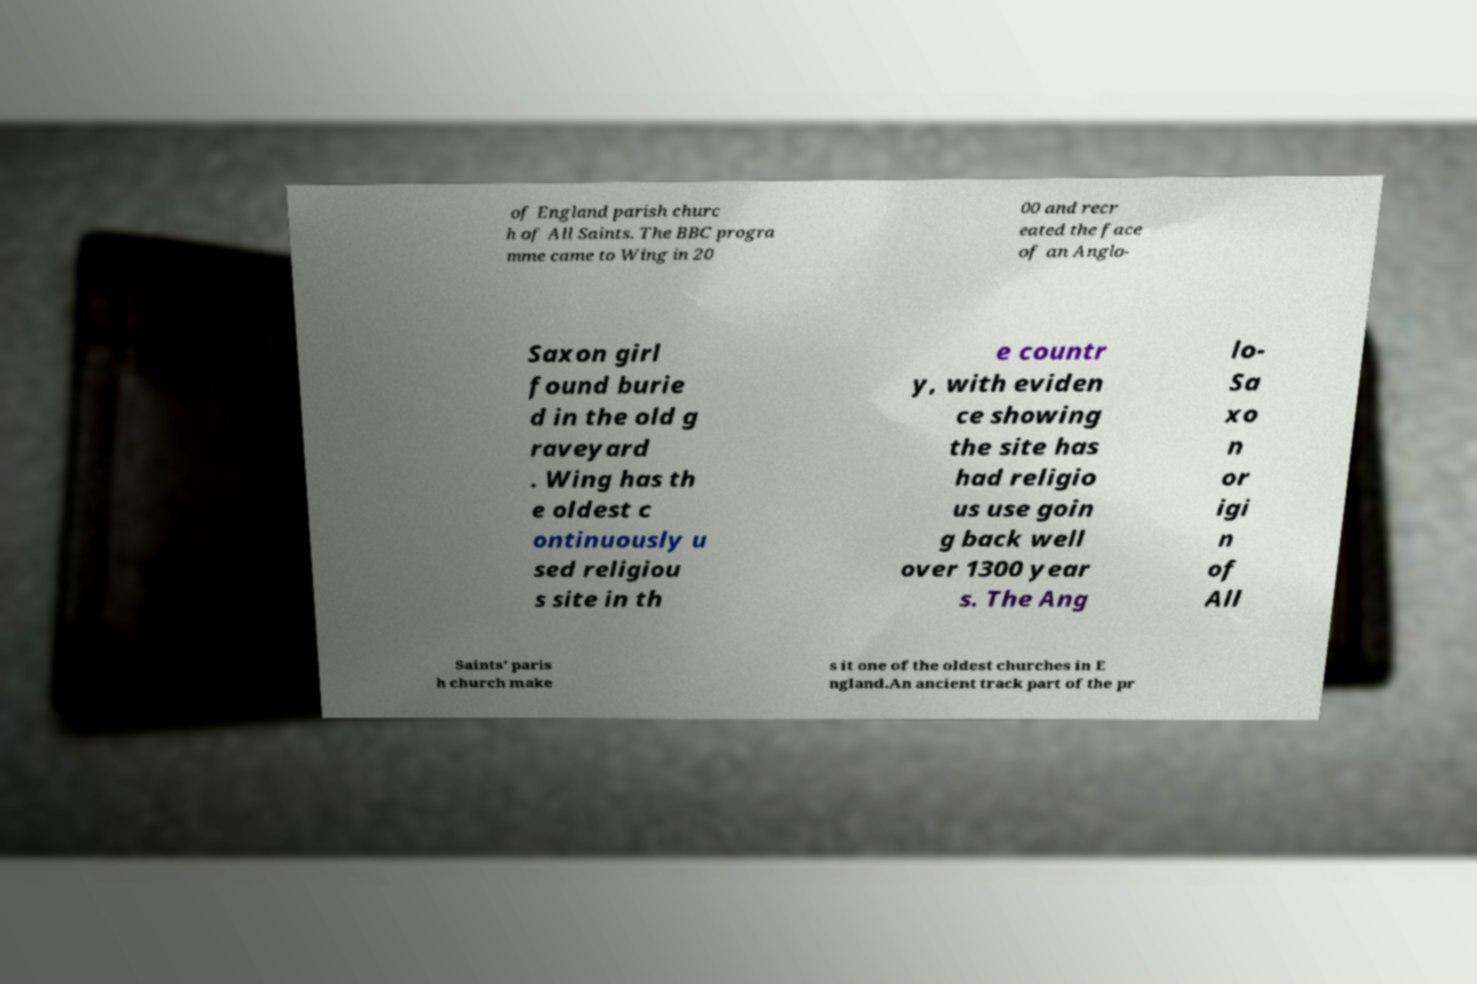Can you read and provide the text displayed in the image?This photo seems to have some interesting text. Can you extract and type it out for me? of England parish churc h of All Saints. The BBC progra mme came to Wing in 20 00 and recr eated the face of an Anglo- Saxon girl found burie d in the old g raveyard . Wing has th e oldest c ontinuously u sed religiou s site in th e countr y, with eviden ce showing the site has had religio us use goin g back well over 1300 year s. The Ang lo- Sa xo n or igi n of All Saints' paris h church make s it one of the oldest churches in E ngland.An ancient track part of the pr 